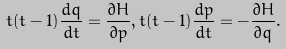Convert formula to latex. <formula><loc_0><loc_0><loc_500><loc_500>t ( t - 1 ) \frac { d q } { d t } = \frac { \partial H } { \partial p } , t ( t - 1 ) \frac { d p } { d t } = - \frac { \partial H } { \partial q } .</formula> 